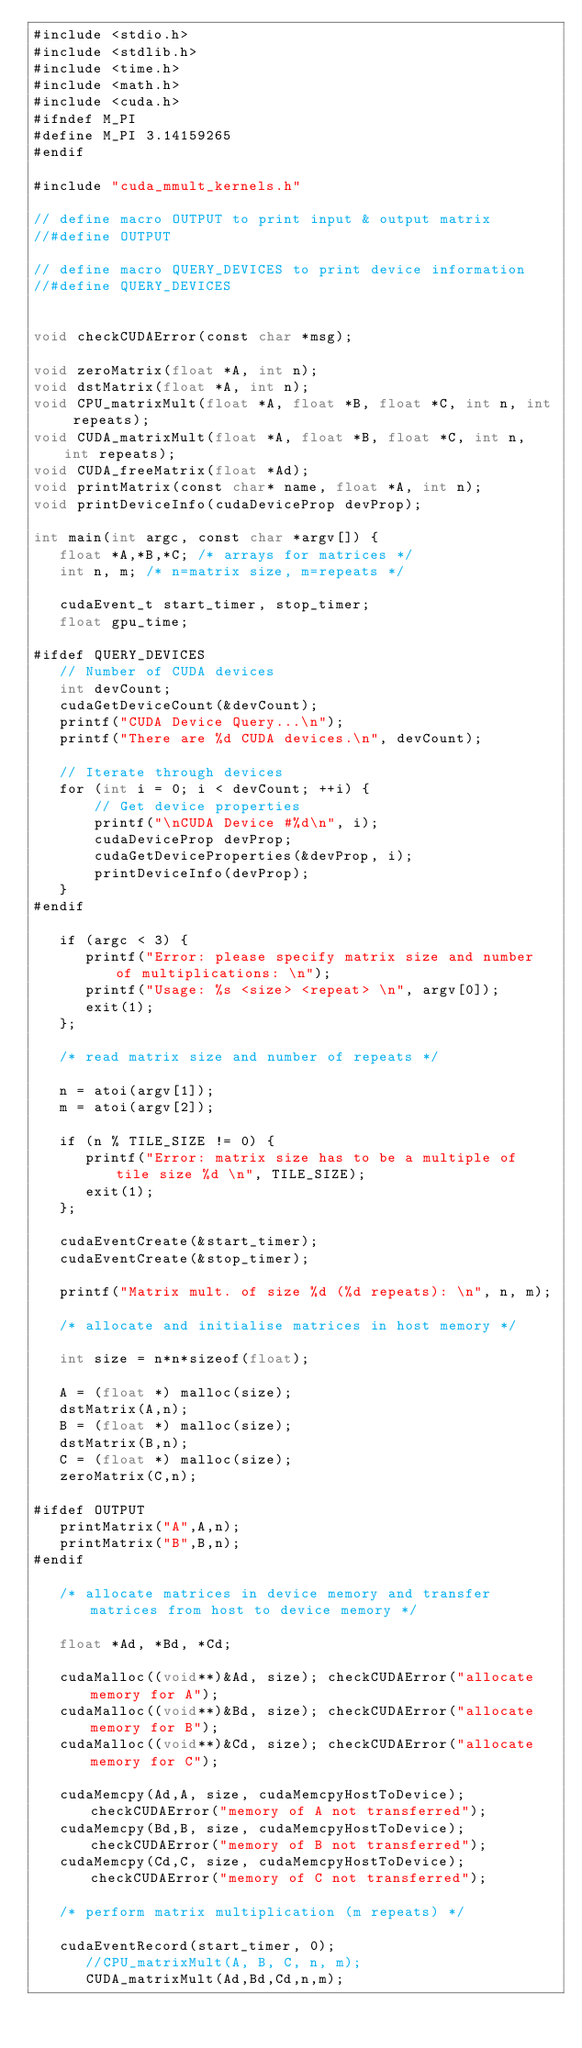<code> <loc_0><loc_0><loc_500><loc_500><_Cuda_>#include <stdio.h>
#include <stdlib.h>
#include <time.h>
#include <math.h>
#include <cuda.h>
#ifndef M_PI
#define M_PI 3.14159265
#endif

#include "cuda_mmult_kernels.h"

// define macro OUTPUT to print input & output matrix
//#define OUTPUT

// define macro QUERY_DEVICES to print device information
//#define QUERY_DEVICES


void checkCUDAError(const char *msg);

void zeroMatrix(float *A, int n);
void dstMatrix(float *A, int n);
void CPU_matrixMult(float *A, float *B, float *C, int n, int repeats);
void CUDA_matrixMult(float *A, float *B, float *C, int n, int repeats);
void CUDA_freeMatrix(float *Ad);
void printMatrix(const char* name, float *A, int n);
void printDeviceInfo(cudaDeviceProp devProp);

int main(int argc, const char *argv[]) {
   float *A,*B,*C; /* arrays for matrices */
   int n, m; /* n=matrix size, m=repeats */
   
   cudaEvent_t start_timer, stop_timer;
   float gpu_time;
 
#ifdef QUERY_DEVICES
   // Number of CUDA devices
   int devCount;
   cudaGetDeviceCount(&devCount);
   printf("CUDA Device Query...\n");
   printf("There are %d CUDA devices.\n", devCount);

   // Iterate through devices
   for (int i = 0; i < devCount; ++i) {
       // Get device properties
       printf("\nCUDA Device #%d\n", i);
       cudaDeviceProp devProp;
       cudaGetDeviceProperties(&devProp, i);
       printDeviceInfo(devProp);
   }
#endif

   if (argc < 3) {
      printf("Error: please specify matrix size and number of multiplications: \n");
      printf("Usage: %s <size> <repeat> \n", argv[0]);
      exit(1);      
   };
   
   /* read matrix size and number of repeats */

   n = atoi(argv[1]);
   m = atoi(argv[2]);

   if (n % TILE_SIZE != 0) {
      printf("Error: matrix size has to be a multiple of tile size %d \n", TILE_SIZE);
      exit(1);      
   };

   cudaEventCreate(&start_timer);
   cudaEventCreate(&stop_timer);

   printf("Matrix mult. of size %d (%d repeats): \n", n, m);

   /* allocate and initialise matrices in host memory */

   int size = n*n*sizeof(float);

   A = (float *) malloc(size);
   dstMatrix(A,n);
   B = (float *) malloc(size);
   dstMatrix(B,n);
   C = (float *) malloc(size);
   zeroMatrix(C,n);
   
#ifdef OUTPUT
   printMatrix("A",A,n);
   printMatrix("B",B,n); 
#endif

   /* allocate matrices in device memory and transfer matrices from host to device memory */
   
   float *Ad, *Bd, *Cd;
   
   cudaMalloc((void**)&Ad, size); checkCUDAError("allocate memory for A");
   cudaMalloc((void**)&Bd, size); checkCUDAError("allocate memory for B");
   cudaMalloc((void**)&Cd, size); checkCUDAError("allocate memory for C");

   cudaMemcpy(Ad,A, size, cudaMemcpyHostToDevice); checkCUDAError("memory of A not transferred");
   cudaMemcpy(Bd,B, size, cudaMemcpyHostToDevice); checkCUDAError("memory of B not transferred");
   cudaMemcpy(Cd,C, size, cudaMemcpyHostToDevice); checkCUDAError("memory of C not transferred");

   /* perform matrix multiplication (m repeats) */

   cudaEventRecord(start_timer, 0);
      //CPU_matrixMult(A, B, C, n, m);
      CUDA_matrixMult(Ad,Bd,Cd,n,m);</code> 